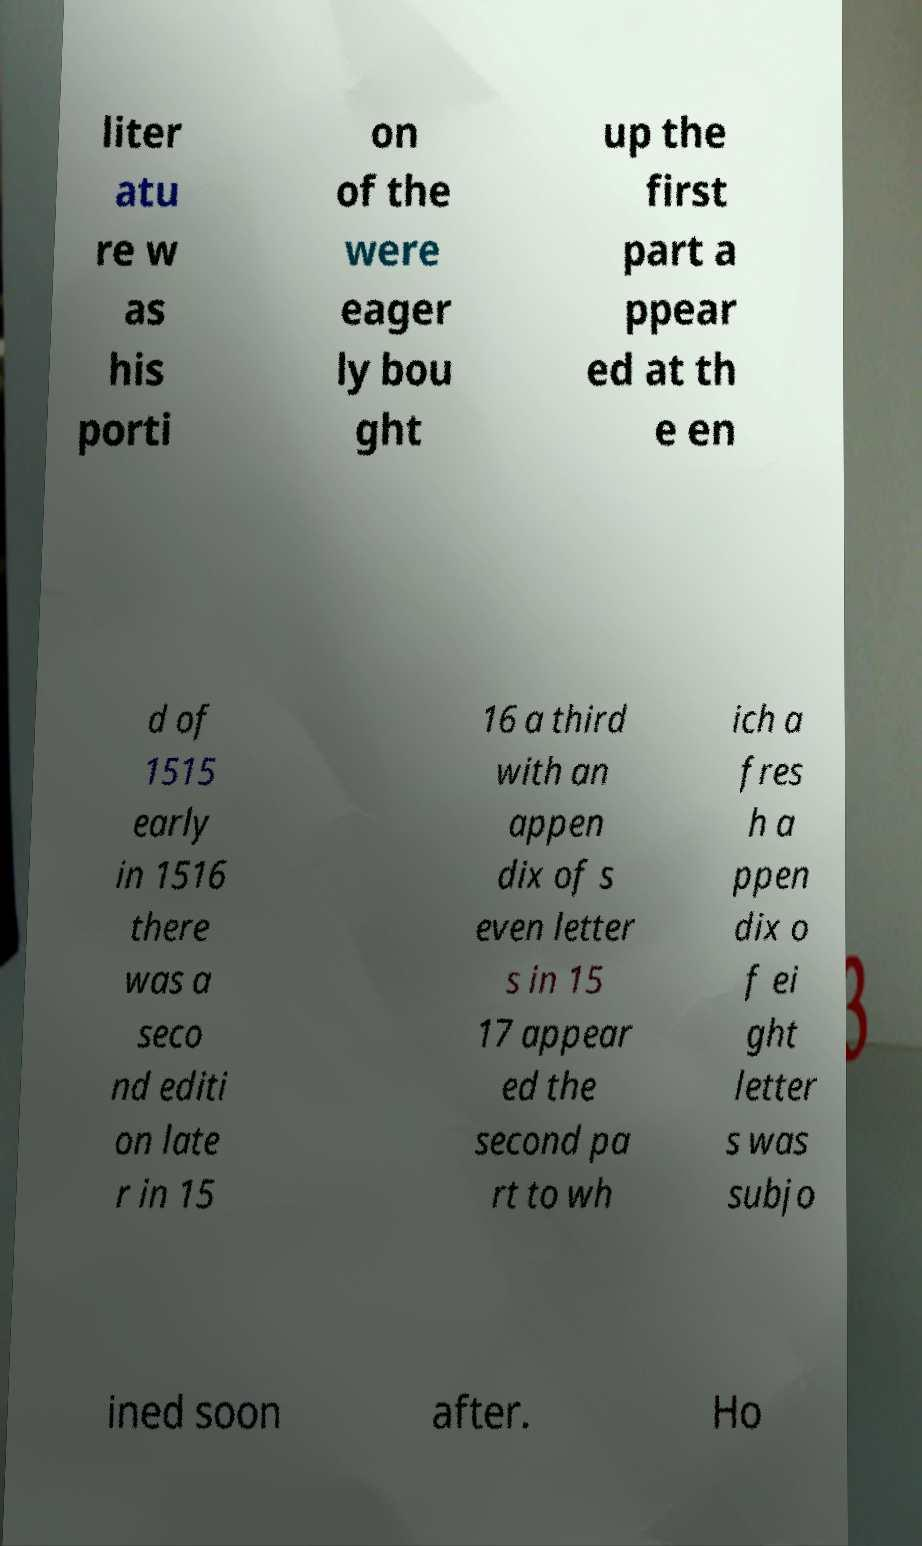Please identify and transcribe the text found in this image. liter atu re w as his porti on of the were eager ly bou ght up the first part a ppear ed at th e en d of 1515 early in 1516 there was a seco nd editi on late r in 15 16 a third with an appen dix of s even letter s in 15 17 appear ed the second pa rt to wh ich a fres h a ppen dix o f ei ght letter s was subjo ined soon after. Ho 